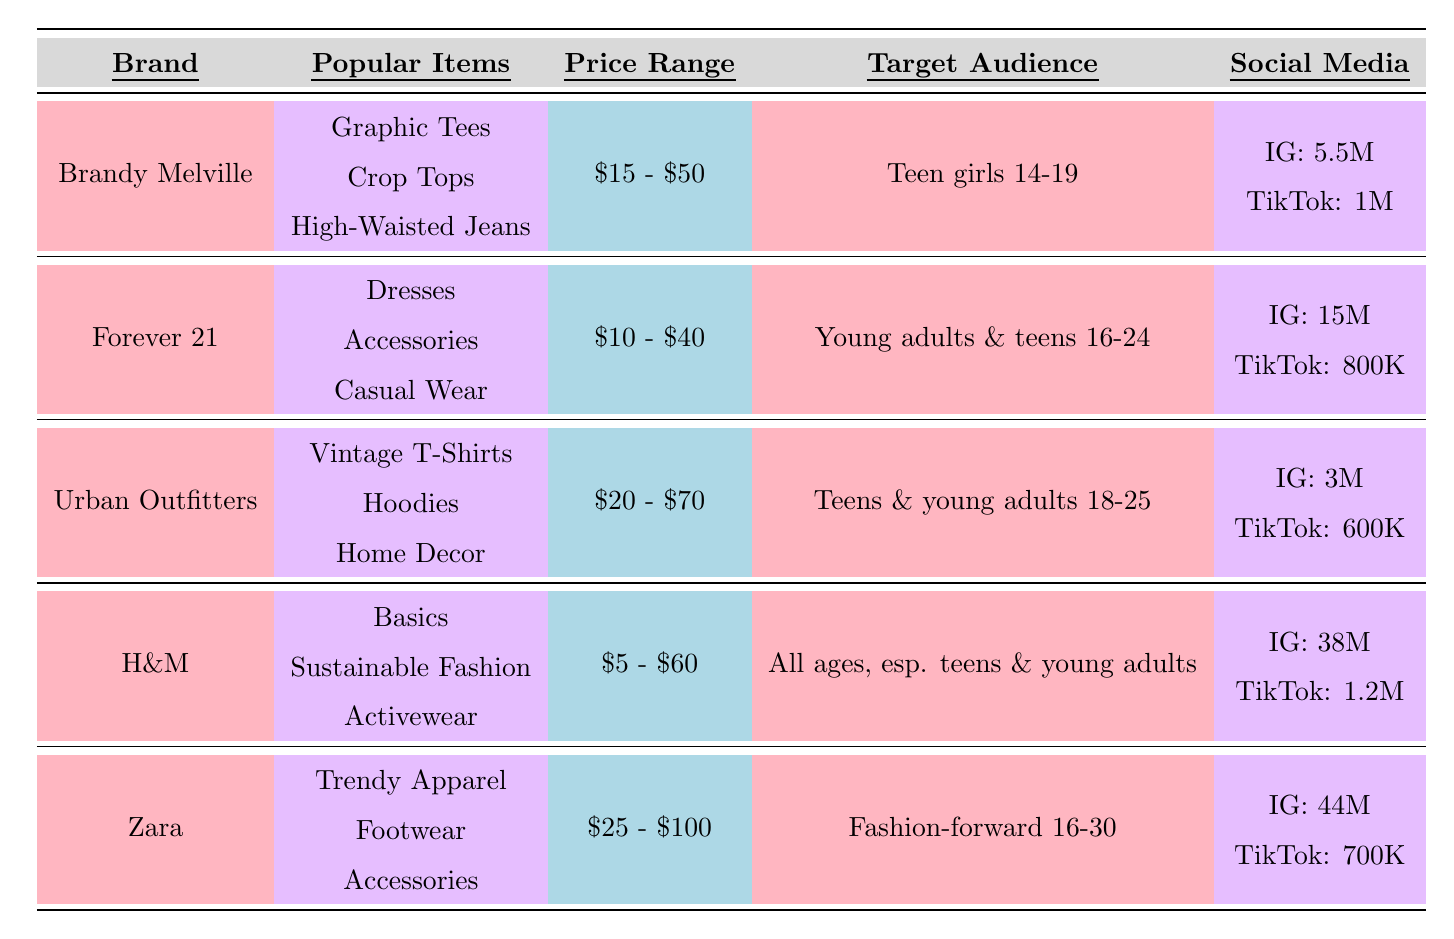What are the popular items for Brandy Melville? The table lists the popular items for Brandy Melville as Graphic Tees, Crop Tops, and High-Waisted Jeans.
Answer: Graphic Tees, Crop Tops, High-Waisted Jeans Which brand has the highest Instagram followers? According to the table, H&M has the highest Instagram followers at 38 million.
Answer: H&M What is the price range of Forever 21? The price range for Forever 21 is listed in the table as $10 - $40.
Answer: $10 - $40 Is Zara targeted only at teens? The table indicates that Zara is targeted toward fashion-forward teens and young adults aged 16-30, which includes both teens and young adults. Thus, the answer is no.
Answer: No Which brand has the most social media presence on TikTok? H&M has 1.2 million TikTok followers, which is the highest compared to other brands listed.
Answer: H&M What is the average price range of Urban Outfitters and Zara? The price range for Urban Outfitters is $20 - $70, and for Zara, it is $25 - $100. To find the average: (70 + 100) / 2 = 85 / 2 = 42.5.
Answer: $42.5 Are graphic tees popular among the items listed for H&M? The table does not list Graphic Tees as a popular item for H&M; instead, it mentions Basics, Sustainable Fashion, and Activewear. Therefore, the answer is no.
Answer: No If we combine the Instagram followers of Brandy Melville and Urban Outfitters, what is the total? Brandy Melville has 5.5 million and Urban Outfitters has 3 million Instagram followers. To find the total: 5.5 + 3 = 8.5 million.
Answer: 8.5 million Which brand has the lowest average price range? The lowest average price range is for H&M at $5 - $60, which is lower than the other brands.
Answer: H&M Which brand targets a wider age range, H&M or Forever 21? H&M targets all ages, particularly teens and young adults, while Forever 21 targets young adults and teens aged 16-24. Therefore, H&M targets a wider range.
Answer: H&M What is the median price range of all the brands listed? The price ranges are $15 - $50, $10 - $40, $20 - $70, $5 - $60, and $25 - $100. Ordering them lowest to highest gives: $5 - $60, $10 - $40, $15 - $50, $20 - $70, $25 - $100. The median is the middle value, which is $15 - $50.
Answer: $15 - $50 